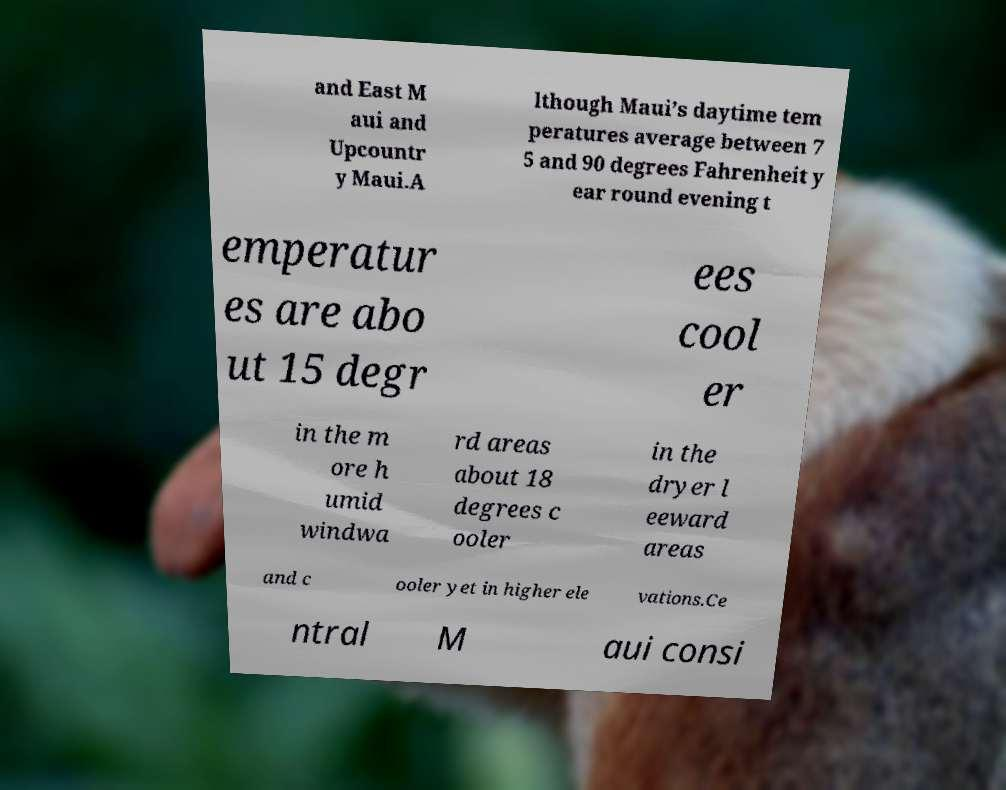Can you read and provide the text displayed in the image?This photo seems to have some interesting text. Can you extract and type it out for me? and East M aui and Upcountr y Maui.A lthough Maui’s daytime tem peratures average between 7 5 and 90 degrees Fahrenheit y ear round evening t emperatur es are abo ut 15 degr ees cool er in the m ore h umid windwa rd areas about 18 degrees c ooler in the dryer l eeward areas and c ooler yet in higher ele vations.Ce ntral M aui consi 